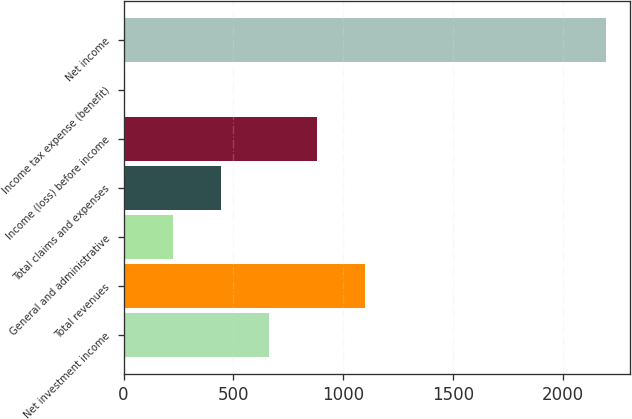Convert chart. <chart><loc_0><loc_0><loc_500><loc_500><bar_chart><fcel>Net investment income<fcel>Total revenues<fcel>General and administrative<fcel>Total claims and expenses<fcel>Income (loss) before income<fcel>Income tax expense (benefit)<fcel>Net income<nl><fcel>662.9<fcel>1101.5<fcel>224.3<fcel>443.6<fcel>882.2<fcel>5<fcel>2198<nl></chart> 